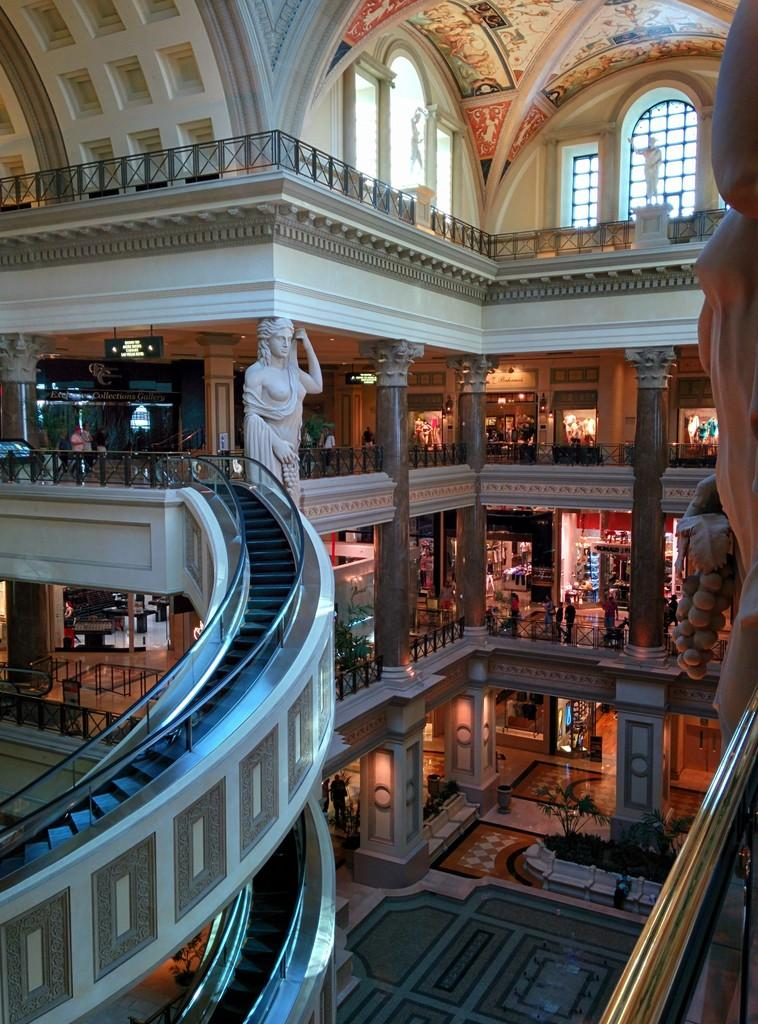What type of location is depicted in the image? The image shows the inside view of a mall. What can be seen in the middle of the image? There is a white color statue in the middle of the image. What are the elevators used for in the mall? The elevators are present beside the statue for people to move between floors. What type of land is visible in the image? The image does not show any land; it depicts the inside view of a mall. 